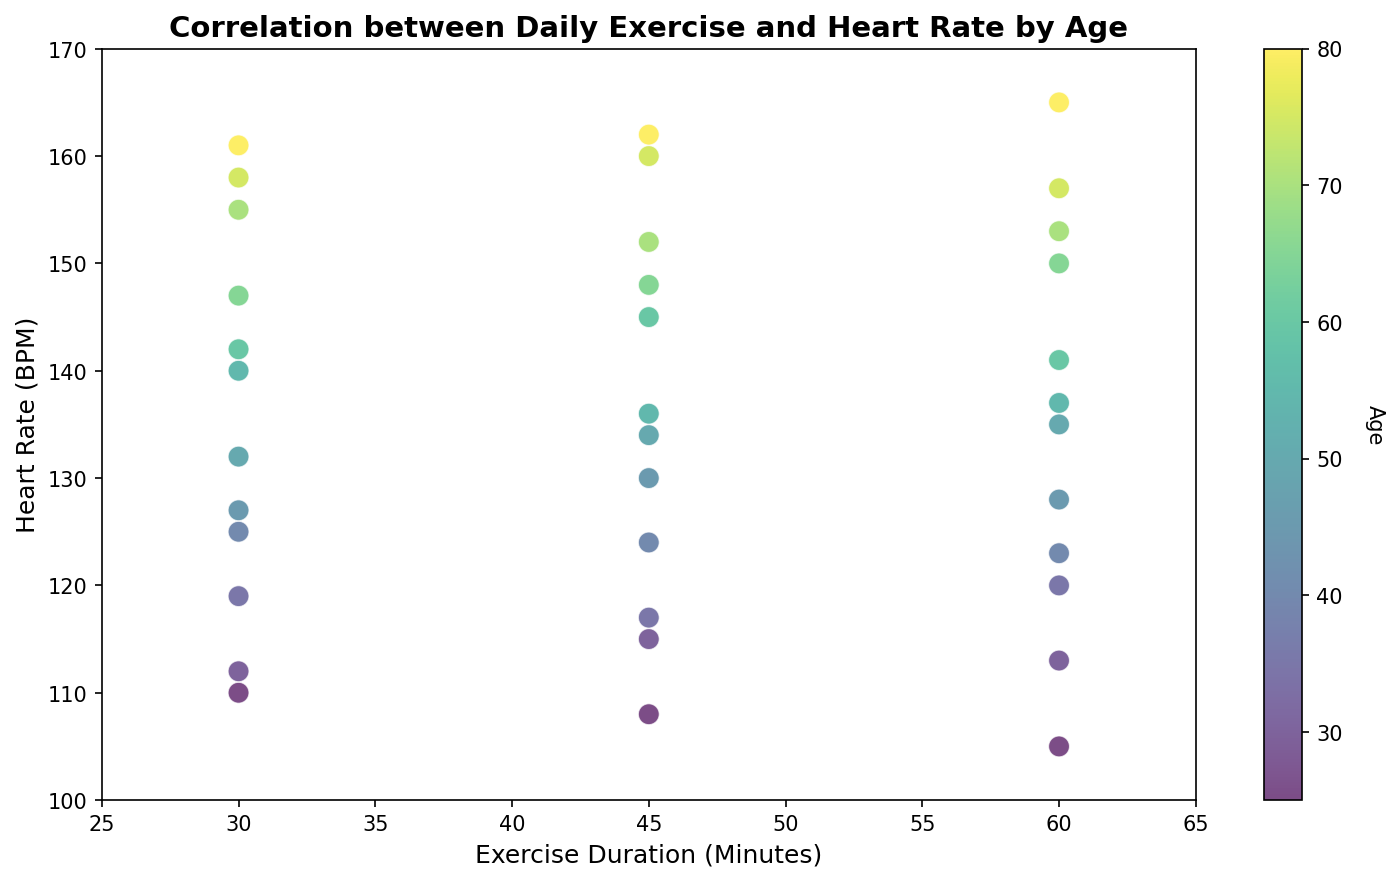What is the general trend between exercise duration and heart rate for different ages? Examining the overall scatter plot, it shows a positive correlation where an increase in exercise duration generally corresponds to a higher heart rate, especially as age increases.
Answer: Positive correlation Which age group shows the highest heart rate at the same exercise duration? By observing the color gradient on the scatter plot, it is visible that older age groups (e.g., those aged 75 or 80) have the highest heart rates compared to the younger age groups for the same exercise duration.
Answer: Older age groups (75, 80) What is the heart rate for a 35-year-old person doing 60 minutes of exercise? Locate the dots that correspond to 60 minutes of exercise duration and identify the one colored for a 35-year-old which is closest to heart rate 120 BPM.
Answer: 120 BPM Do younger individuals show a lower heart rate for the same exercise duration compared to older individuals? Compare the colors of points at different exercise durations and heart rates, noting that younger age groups (closer to green/yellow) exhibit lower heart rates for the same exercise duration compared to older age groups (orange/purple).
Answer: Yes What is the difference in heart rate between a 40-year-old exercising for 45 minutes and a 60-year-old exercising for 45 minutes? Identify the points for 40-year-old and 60-year-old individuals at 45 minutes of exercise duration. The 40-year-old has a heart rate close to 124 BPM and the 60-year-old around 142 BPM. The difference is 142 - 124.
Answer: 18 BPM Do any 25-year-olds ever exceed a heart rate of 110 BPM? Check the color and position of the points corresponding to 25-year-olds; none of the heart rates for this age group exceed 110 BPM as per the scatter plot data.
Answer: No How does heart rate differ between 30 minutes and 60 minutes of exercise for a 65-year-old? For a 65-year-old, find the points at 30 minutes (around 147 BPM) and at 60 minutes (around 150 BPM). Calculate the difference, 150 - 147.
Answer: 3 BPM Is there an evident outlier in any age group or exercise duration? Scanning through the scatter plot points, there are no apparent outliers as all the data points seem to align with the overall trend of increasing heart rate with more exercise duration and higher age.
Answer: No What is the average heart rate for a 50-year-old across different exercise durations? Identify the heart rates for a 50-year-old at different exercise durations: 135, 134, and 132 BPM. Calculate the average: (135 + 134 + 132) / 3 = 133.67 BPM.
Answer: 133.67 BPM 